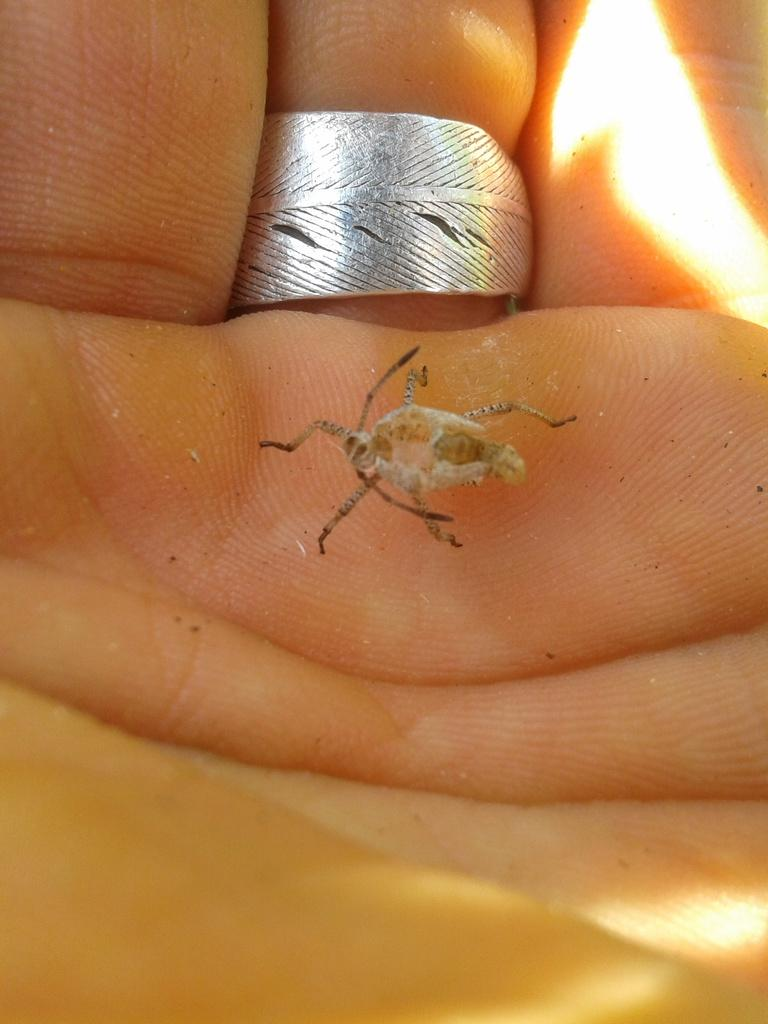What type of creature is in the image? There is an insect in the image. What color is the insect? The insect is brown in color. What is the insect's interaction with the person in the image? A person is holding the insect in the image. Can you describe any accessory the person is wearing? The person is wearing a ring. What type of learning material is the person using while holding the insect? There is no learning material present in the image, and the person is not using any while holding the insect. 